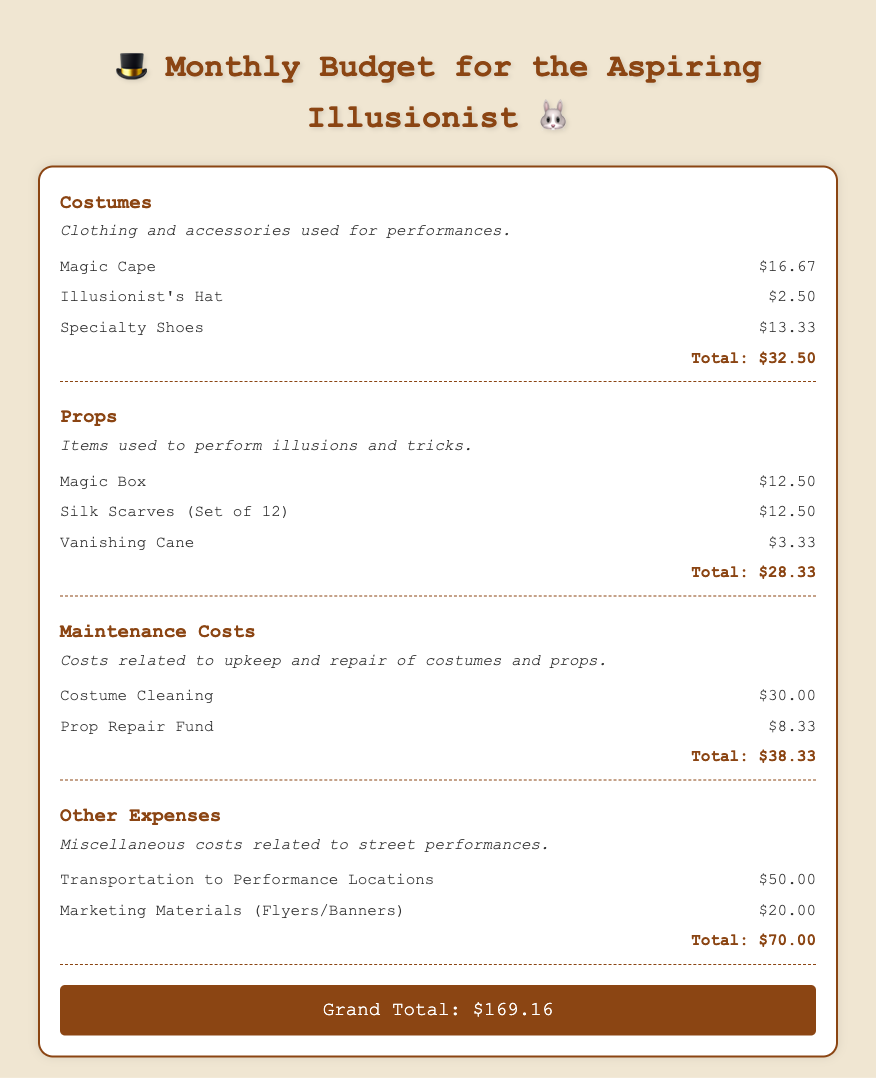What is the total cost of costumes? The total for costumes is listed at the bottom of that section, which is the sum of all costume items.
Answer: $32.50 What item costs the least in the props category? The item with the lowest cost in the props category is the Vanishing Cane.
Answer: $3.33 What is the maintenance cost for costume cleaning? The cost for costume cleaning is specified in the maintenance section as $30.00.
Answer: $30.00 What is included in the other expenses category? The other expenses category includes transportation to performance locations and marketing materials.
Answer: Transportation and marketing materials What is the grand total for the monthly budget? The grand total is derived from adding all category totals and is shown at the bottom of the document.
Answer: $169.16 How much is allocated to the Prop Repair Fund? The Prop Repair Fund amount is given in the maintenance costs section.
Answer: $8.33 What is the cost of the Magic Box? The price of the Magic Box is mentioned specifically in the props category.
Answer: $12.50 What percentage of the total budget is spent on other expenses? To find this, divide the total of other expenses by the grand total and multiply by 100.
Answer: 41.5% What are specialty shoes categorized under? Specialty shoes fall under the category of costumes as stated in the document.
Answer: Costumes 